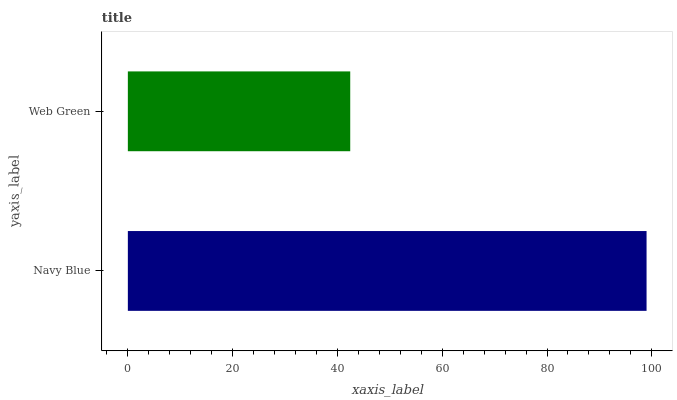Is Web Green the minimum?
Answer yes or no. Yes. Is Navy Blue the maximum?
Answer yes or no. Yes. Is Web Green the maximum?
Answer yes or no. No. Is Navy Blue greater than Web Green?
Answer yes or no. Yes. Is Web Green less than Navy Blue?
Answer yes or no. Yes. Is Web Green greater than Navy Blue?
Answer yes or no. No. Is Navy Blue less than Web Green?
Answer yes or no. No. Is Navy Blue the high median?
Answer yes or no. Yes. Is Web Green the low median?
Answer yes or no. Yes. Is Web Green the high median?
Answer yes or no. No. Is Navy Blue the low median?
Answer yes or no. No. 